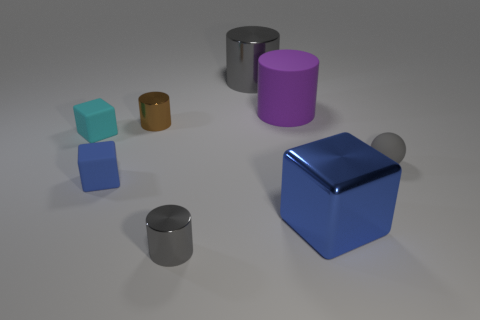Add 2 large metal cylinders. How many objects exist? 10 Subtract all blocks. How many objects are left? 5 Subtract 0 red spheres. How many objects are left? 8 Subtract all big rubber cylinders. Subtract all big purple cylinders. How many objects are left? 6 Add 1 blue blocks. How many blue blocks are left? 3 Add 4 big purple blocks. How many big purple blocks exist? 4 